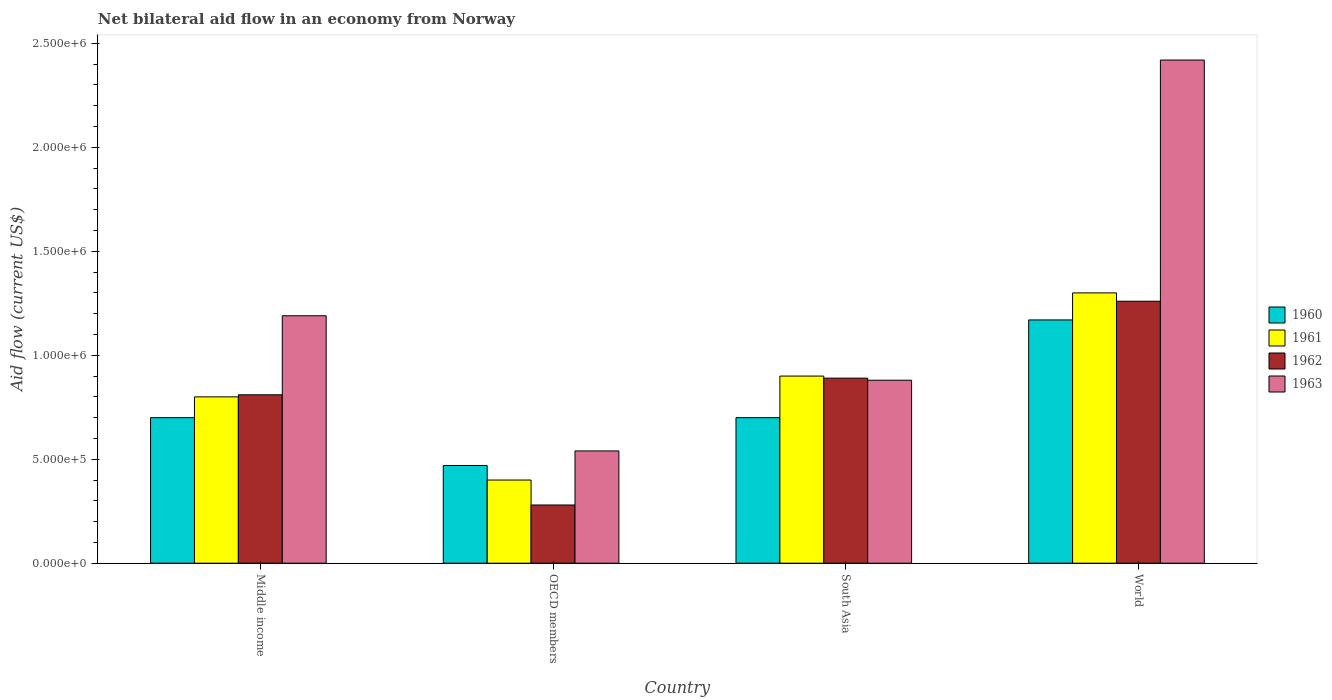Are the number of bars per tick equal to the number of legend labels?
Give a very brief answer. Yes. Are the number of bars on each tick of the X-axis equal?
Offer a very short reply. Yes. How many bars are there on the 3rd tick from the right?
Offer a terse response. 4. What is the label of the 1st group of bars from the left?
Your response must be concise. Middle income. In how many cases, is the number of bars for a given country not equal to the number of legend labels?
Offer a terse response. 0. What is the net bilateral aid flow in 1963 in OECD members?
Offer a terse response. 5.40e+05. Across all countries, what is the maximum net bilateral aid flow in 1963?
Your answer should be compact. 2.42e+06. Across all countries, what is the minimum net bilateral aid flow in 1963?
Offer a very short reply. 5.40e+05. In which country was the net bilateral aid flow in 1963 minimum?
Make the answer very short. OECD members. What is the total net bilateral aid flow in 1960 in the graph?
Keep it short and to the point. 3.04e+06. What is the difference between the net bilateral aid flow in 1963 in Middle income and that in OECD members?
Provide a succinct answer. 6.50e+05. What is the difference between the net bilateral aid flow in 1961 in South Asia and the net bilateral aid flow in 1960 in Middle income?
Provide a succinct answer. 2.00e+05. What is the average net bilateral aid flow in 1960 per country?
Offer a very short reply. 7.60e+05. In how many countries, is the net bilateral aid flow in 1962 greater than 2100000 US$?
Keep it short and to the point. 0. What is the ratio of the net bilateral aid flow in 1963 in OECD members to that in World?
Your answer should be compact. 0.22. Is the net bilateral aid flow in 1963 in Middle income less than that in South Asia?
Provide a short and direct response. No. Is the difference between the net bilateral aid flow in 1961 in South Asia and World greater than the difference between the net bilateral aid flow in 1960 in South Asia and World?
Offer a very short reply. Yes. What is the difference between the highest and the second highest net bilateral aid flow in 1962?
Give a very brief answer. 4.50e+05. What is the difference between the highest and the lowest net bilateral aid flow in 1962?
Offer a terse response. 9.80e+05. Is the sum of the net bilateral aid flow in 1963 in South Asia and World greater than the maximum net bilateral aid flow in 1961 across all countries?
Provide a short and direct response. Yes. Is it the case that in every country, the sum of the net bilateral aid flow in 1961 and net bilateral aid flow in 1963 is greater than the sum of net bilateral aid flow in 1962 and net bilateral aid flow in 1960?
Provide a short and direct response. No. What does the 3rd bar from the left in World represents?
Your answer should be compact. 1962. How many countries are there in the graph?
Your answer should be compact. 4. What is the difference between two consecutive major ticks on the Y-axis?
Offer a terse response. 5.00e+05. Are the values on the major ticks of Y-axis written in scientific E-notation?
Provide a short and direct response. Yes. Does the graph contain any zero values?
Your answer should be compact. No. What is the title of the graph?
Your answer should be compact. Net bilateral aid flow in an economy from Norway. What is the label or title of the Y-axis?
Offer a terse response. Aid flow (current US$). What is the Aid flow (current US$) in 1961 in Middle income?
Your answer should be very brief. 8.00e+05. What is the Aid flow (current US$) in 1962 in Middle income?
Offer a terse response. 8.10e+05. What is the Aid flow (current US$) of 1963 in Middle income?
Offer a terse response. 1.19e+06. What is the Aid flow (current US$) of 1962 in OECD members?
Ensure brevity in your answer.  2.80e+05. What is the Aid flow (current US$) in 1963 in OECD members?
Provide a short and direct response. 5.40e+05. What is the Aid flow (current US$) in 1960 in South Asia?
Your answer should be compact. 7.00e+05. What is the Aid flow (current US$) in 1962 in South Asia?
Give a very brief answer. 8.90e+05. What is the Aid flow (current US$) in 1963 in South Asia?
Your answer should be very brief. 8.80e+05. What is the Aid flow (current US$) in 1960 in World?
Your answer should be compact. 1.17e+06. What is the Aid flow (current US$) of 1961 in World?
Your answer should be compact. 1.30e+06. What is the Aid flow (current US$) in 1962 in World?
Your answer should be very brief. 1.26e+06. What is the Aid flow (current US$) in 1963 in World?
Make the answer very short. 2.42e+06. Across all countries, what is the maximum Aid flow (current US$) in 1960?
Make the answer very short. 1.17e+06. Across all countries, what is the maximum Aid flow (current US$) in 1961?
Offer a terse response. 1.30e+06. Across all countries, what is the maximum Aid flow (current US$) of 1962?
Make the answer very short. 1.26e+06. Across all countries, what is the maximum Aid flow (current US$) of 1963?
Offer a terse response. 2.42e+06. Across all countries, what is the minimum Aid flow (current US$) in 1961?
Your answer should be very brief. 4.00e+05. Across all countries, what is the minimum Aid flow (current US$) in 1963?
Offer a terse response. 5.40e+05. What is the total Aid flow (current US$) of 1960 in the graph?
Your answer should be very brief. 3.04e+06. What is the total Aid flow (current US$) in 1961 in the graph?
Keep it short and to the point. 3.40e+06. What is the total Aid flow (current US$) of 1962 in the graph?
Ensure brevity in your answer.  3.24e+06. What is the total Aid flow (current US$) in 1963 in the graph?
Offer a terse response. 5.03e+06. What is the difference between the Aid flow (current US$) of 1961 in Middle income and that in OECD members?
Offer a terse response. 4.00e+05. What is the difference between the Aid flow (current US$) of 1962 in Middle income and that in OECD members?
Make the answer very short. 5.30e+05. What is the difference between the Aid flow (current US$) of 1963 in Middle income and that in OECD members?
Keep it short and to the point. 6.50e+05. What is the difference between the Aid flow (current US$) in 1960 in Middle income and that in South Asia?
Your answer should be compact. 0. What is the difference between the Aid flow (current US$) of 1963 in Middle income and that in South Asia?
Your response must be concise. 3.10e+05. What is the difference between the Aid flow (current US$) of 1960 in Middle income and that in World?
Ensure brevity in your answer.  -4.70e+05. What is the difference between the Aid flow (current US$) of 1961 in Middle income and that in World?
Your answer should be compact. -5.00e+05. What is the difference between the Aid flow (current US$) in 1962 in Middle income and that in World?
Make the answer very short. -4.50e+05. What is the difference between the Aid flow (current US$) in 1963 in Middle income and that in World?
Make the answer very short. -1.23e+06. What is the difference between the Aid flow (current US$) of 1961 in OECD members and that in South Asia?
Keep it short and to the point. -5.00e+05. What is the difference between the Aid flow (current US$) of 1962 in OECD members and that in South Asia?
Provide a short and direct response. -6.10e+05. What is the difference between the Aid flow (current US$) of 1963 in OECD members and that in South Asia?
Your answer should be very brief. -3.40e+05. What is the difference between the Aid flow (current US$) in 1960 in OECD members and that in World?
Keep it short and to the point. -7.00e+05. What is the difference between the Aid flow (current US$) of 1961 in OECD members and that in World?
Give a very brief answer. -9.00e+05. What is the difference between the Aid flow (current US$) of 1962 in OECD members and that in World?
Give a very brief answer. -9.80e+05. What is the difference between the Aid flow (current US$) of 1963 in OECD members and that in World?
Give a very brief answer. -1.88e+06. What is the difference between the Aid flow (current US$) of 1960 in South Asia and that in World?
Keep it short and to the point. -4.70e+05. What is the difference between the Aid flow (current US$) in 1961 in South Asia and that in World?
Give a very brief answer. -4.00e+05. What is the difference between the Aid flow (current US$) of 1962 in South Asia and that in World?
Ensure brevity in your answer.  -3.70e+05. What is the difference between the Aid flow (current US$) of 1963 in South Asia and that in World?
Provide a short and direct response. -1.54e+06. What is the difference between the Aid flow (current US$) of 1960 in Middle income and the Aid flow (current US$) of 1962 in OECD members?
Ensure brevity in your answer.  4.20e+05. What is the difference between the Aid flow (current US$) of 1961 in Middle income and the Aid flow (current US$) of 1962 in OECD members?
Ensure brevity in your answer.  5.20e+05. What is the difference between the Aid flow (current US$) in 1960 in Middle income and the Aid flow (current US$) in 1962 in South Asia?
Make the answer very short. -1.90e+05. What is the difference between the Aid flow (current US$) of 1960 in Middle income and the Aid flow (current US$) of 1963 in South Asia?
Provide a short and direct response. -1.80e+05. What is the difference between the Aid flow (current US$) of 1961 in Middle income and the Aid flow (current US$) of 1962 in South Asia?
Ensure brevity in your answer.  -9.00e+04. What is the difference between the Aid flow (current US$) in 1960 in Middle income and the Aid flow (current US$) in 1961 in World?
Give a very brief answer. -6.00e+05. What is the difference between the Aid flow (current US$) in 1960 in Middle income and the Aid flow (current US$) in 1962 in World?
Make the answer very short. -5.60e+05. What is the difference between the Aid flow (current US$) of 1960 in Middle income and the Aid flow (current US$) of 1963 in World?
Your answer should be compact. -1.72e+06. What is the difference between the Aid flow (current US$) in 1961 in Middle income and the Aid flow (current US$) in 1962 in World?
Your answer should be very brief. -4.60e+05. What is the difference between the Aid flow (current US$) in 1961 in Middle income and the Aid flow (current US$) in 1963 in World?
Your answer should be very brief. -1.62e+06. What is the difference between the Aid flow (current US$) in 1962 in Middle income and the Aid flow (current US$) in 1963 in World?
Offer a terse response. -1.61e+06. What is the difference between the Aid flow (current US$) in 1960 in OECD members and the Aid flow (current US$) in 1961 in South Asia?
Provide a succinct answer. -4.30e+05. What is the difference between the Aid flow (current US$) in 1960 in OECD members and the Aid flow (current US$) in 1962 in South Asia?
Keep it short and to the point. -4.20e+05. What is the difference between the Aid flow (current US$) in 1960 in OECD members and the Aid flow (current US$) in 1963 in South Asia?
Offer a terse response. -4.10e+05. What is the difference between the Aid flow (current US$) in 1961 in OECD members and the Aid flow (current US$) in 1962 in South Asia?
Keep it short and to the point. -4.90e+05. What is the difference between the Aid flow (current US$) of 1961 in OECD members and the Aid flow (current US$) of 1963 in South Asia?
Offer a very short reply. -4.80e+05. What is the difference between the Aid flow (current US$) in 1962 in OECD members and the Aid flow (current US$) in 1963 in South Asia?
Your answer should be compact. -6.00e+05. What is the difference between the Aid flow (current US$) in 1960 in OECD members and the Aid flow (current US$) in 1961 in World?
Make the answer very short. -8.30e+05. What is the difference between the Aid flow (current US$) of 1960 in OECD members and the Aid flow (current US$) of 1962 in World?
Your response must be concise. -7.90e+05. What is the difference between the Aid flow (current US$) of 1960 in OECD members and the Aid flow (current US$) of 1963 in World?
Your response must be concise. -1.95e+06. What is the difference between the Aid flow (current US$) in 1961 in OECD members and the Aid flow (current US$) in 1962 in World?
Your answer should be very brief. -8.60e+05. What is the difference between the Aid flow (current US$) in 1961 in OECD members and the Aid flow (current US$) in 1963 in World?
Provide a short and direct response. -2.02e+06. What is the difference between the Aid flow (current US$) of 1962 in OECD members and the Aid flow (current US$) of 1963 in World?
Offer a terse response. -2.14e+06. What is the difference between the Aid flow (current US$) in 1960 in South Asia and the Aid flow (current US$) in 1961 in World?
Keep it short and to the point. -6.00e+05. What is the difference between the Aid flow (current US$) of 1960 in South Asia and the Aid flow (current US$) of 1962 in World?
Offer a terse response. -5.60e+05. What is the difference between the Aid flow (current US$) of 1960 in South Asia and the Aid flow (current US$) of 1963 in World?
Your answer should be very brief. -1.72e+06. What is the difference between the Aid flow (current US$) in 1961 in South Asia and the Aid flow (current US$) in 1962 in World?
Ensure brevity in your answer.  -3.60e+05. What is the difference between the Aid flow (current US$) in 1961 in South Asia and the Aid flow (current US$) in 1963 in World?
Your answer should be very brief. -1.52e+06. What is the difference between the Aid flow (current US$) in 1962 in South Asia and the Aid flow (current US$) in 1963 in World?
Offer a terse response. -1.53e+06. What is the average Aid flow (current US$) of 1960 per country?
Provide a short and direct response. 7.60e+05. What is the average Aid flow (current US$) of 1961 per country?
Keep it short and to the point. 8.50e+05. What is the average Aid flow (current US$) in 1962 per country?
Make the answer very short. 8.10e+05. What is the average Aid flow (current US$) of 1963 per country?
Your answer should be compact. 1.26e+06. What is the difference between the Aid flow (current US$) of 1960 and Aid flow (current US$) of 1963 in Middle income?
Offer a very short reply. -4.90e+05. What is the difference between the Aid flow (current US$) of 1961 and Aid flow (current US$) of 1963 in Middle income?
Provide a short and direct response. -3.90e+05. What is the difference between the Aid flow (current US$) in 1962 and Aid flow (current US$) in 1963 in Middle income?
Give a very brief answer. -3.80e+05. What is the difference between the Aid flow (current US$) in 1960 and Aid flow (current US$) in 1961 in OECD members?
Make the answer very short. 7.00e+04. What is the difference between the Aid flow (current US$) in 1962 and Aid flow (current US$) in 1963 in OECD members?
Give a very brief answer. -2.60e+05. What is the difference between the Aid flow (current US$) in 1960 and Aid flow (current US$) in 1961 in World?
Provide a succinct answer. -1.30e+05. What is the difference between the Aid flow (current US$) in 1960 and Aid flow (current US$) in 1963 in World?
Your answer should be very brief. -1.25e+06. What is the difference between the Aid flow (current US$) of 1961 and Aid flow (current US$) of 1962 in World?
Your response must be concise. 4.00e+04. What is the difference between the Aid flow (current US$) of 1961 and Aid flow (current US$) of 1963 in World?
Give a very brief answer. -1.12e+06. What is the difference between the Aid flow (current US$) of 1962 and Aid flow (current US$) of 1963 in World?
Offer a very short reply. -1.16e+06. What is the ratio of the Aid flow (current US$) in 1960 in Middle income to that in OECD members?
Your answer should be compact. 1.49. What is the ratio of the Aid flow (current US$) of 1961 in Middle income to that in OECD members?
Your response must be concise. 2. What is the ratio of the Aid flow (current US$) in 1962 in Middle income to that in OECD members?
Provide a succinct answer. 2.89. What is the ratio of the Aid flow (current US$) of 1963 in Middle income to that in OECD members?
Your response must be concise. 2.2. What is the ratio of the Aid flow (current US$) in 1960 in Middle income to that in South Asia?
Ensure brevity in your answer.  1. What is the ratio of the Aid flow (current US$) in 1962 in Middle income to that in South Asia?
Your response must be concise. 0.91. What is the ratio of the Aid flow (current US$) of 1963 in Middle income to that in South Asia?
Provide a succinct answer. 1.35. What is the ratio of the Aid flow (current US$) in 1960 in Middle income to that in World?
Offer a terse response. 0.6. What is the ratio of the Aid flow (current US$) in 1961 in Middle income to that in World?
Offer a very short reply. 0.62. What is the ratio of the Aid flow (current US$) of 1962 in Middle income to that in World?
Provide a short and direct response. 0.64. What is the ratio of the Aid flow (current US$) of 1963 in Middle income to that in World?
Give a very brief answer. 0.49. What is the ratio of the Aid flow (current US$) of 1960 in OECD members to that in South Asia?
Offer a very short reply. 0.67. What is the ratio of the Aid flow (current US$) of 1961 in OECD members to that in South Asia?
Give a very brief answer. 0.44. What is the ratio of the Aid flow (current US$) in 1962 in OECD members to that in South Asia?
Provide a succinct answer. 0.31. What is the ratio of the Aid flow (current US$) of 1963 in OECD members to that in South Asia?
Provide a succinct answer. 0.61. What is the ratio of the Aid flow (current US$) of 1960 in OECD members to that in World?
Provide a succinct answer. 0.4. What is the ratio of the Aid flow (current US$) in 1961 in OECD members to that in World?
Offer a very short reply. 0.31. What is the ratio of the Aid flow (current US$) in 1962 in OECD members to that in World?
Make the answer very short. 0.22. What is the ratio of the Aid flow (current US$) of 1963 in OECD members to that in World?
Offer a very short reply. 0.22. What is the ratio of the Aid flow (current US$) in 1960 in South Asia to that in World?
Your response must be concise. 0.6. What is the ratio of the Aid flow (current US$) in 1961 in South Asia to that in World?
Your answer should be compact. 0.69. What is the ratio of the Aid flow (current US$) in 1962 in South Asia to that in World?
Offer a terse response. 0.71. What is the ratio of the Aid flow (current US$) in 1963 in South Asia to that in World?
Provide a short and direct response. 0.36. What is the difference between the highest and the second highest Aid flow (current US$) in 1960?
Offer a very short reply. 4.70e+05. What is the difference between the highest and the second highest Aid flow (current US$) in 1963?
Provide a short and direct response. 1.23e+06. What is the difference between the highest and the lowest Aid flow (current US$) of 1960?
Your answer should be compact. 7.00e+05. What is the difference between the highest and the lowest Aid flow (current US$) of 1961?
Make the answer very short. 9.00e+05. What is the difference between the highest and the lowest Aid flow (current US$) of 1962?
Give a very brief answer. 9.80e+05. What is the difference between the highest and the lowest Aid flow (current US$) of 1963?
Offer a terse response. 1.88e+06. 